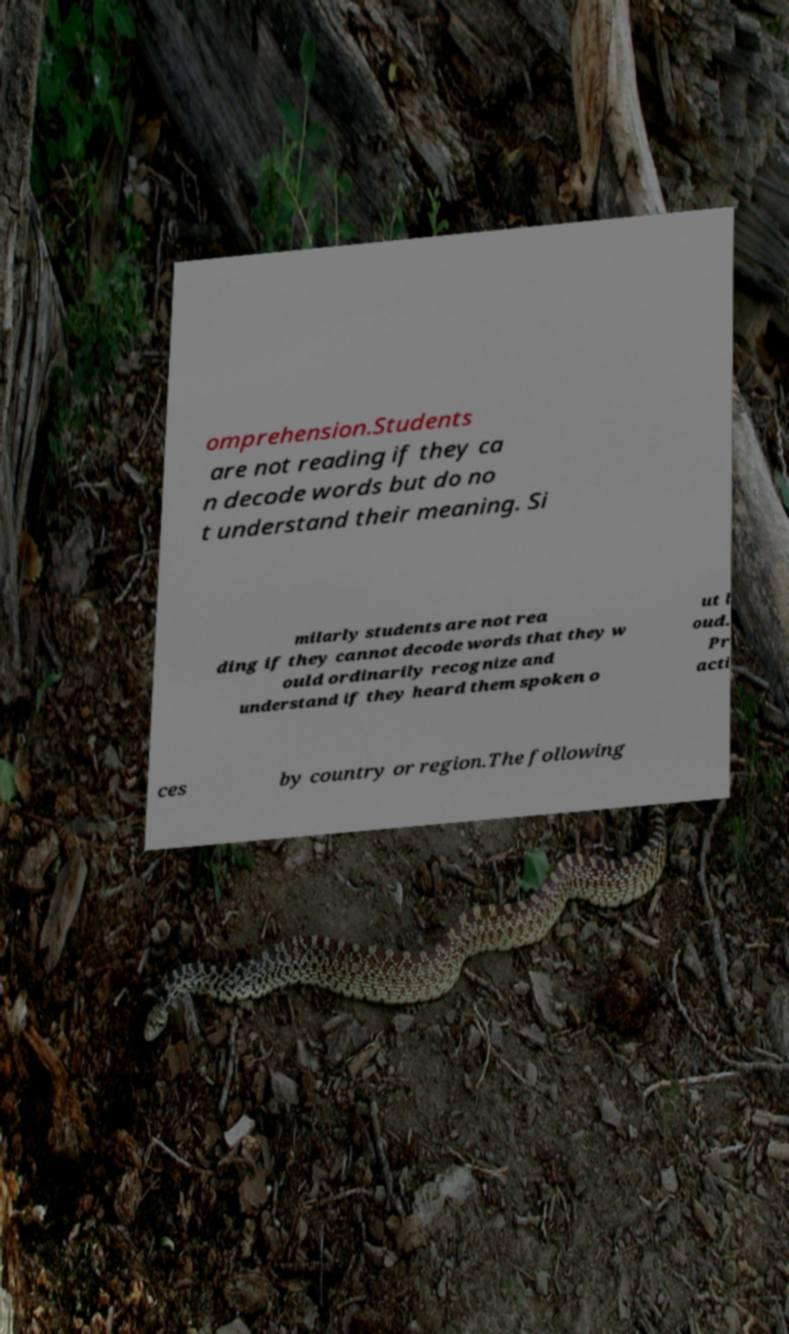For documentation purposes, I need the text within this image transcribed. Could you provide that? omprehension.Students are not reading if they ca n decode words but do no t understand their meaning. Si milarly students are not rea ding if they cannot decode words that they w ould ordinarily recognize and understand if they heard them spoken o ut l oud. Pr acti ces by country or region.The following 